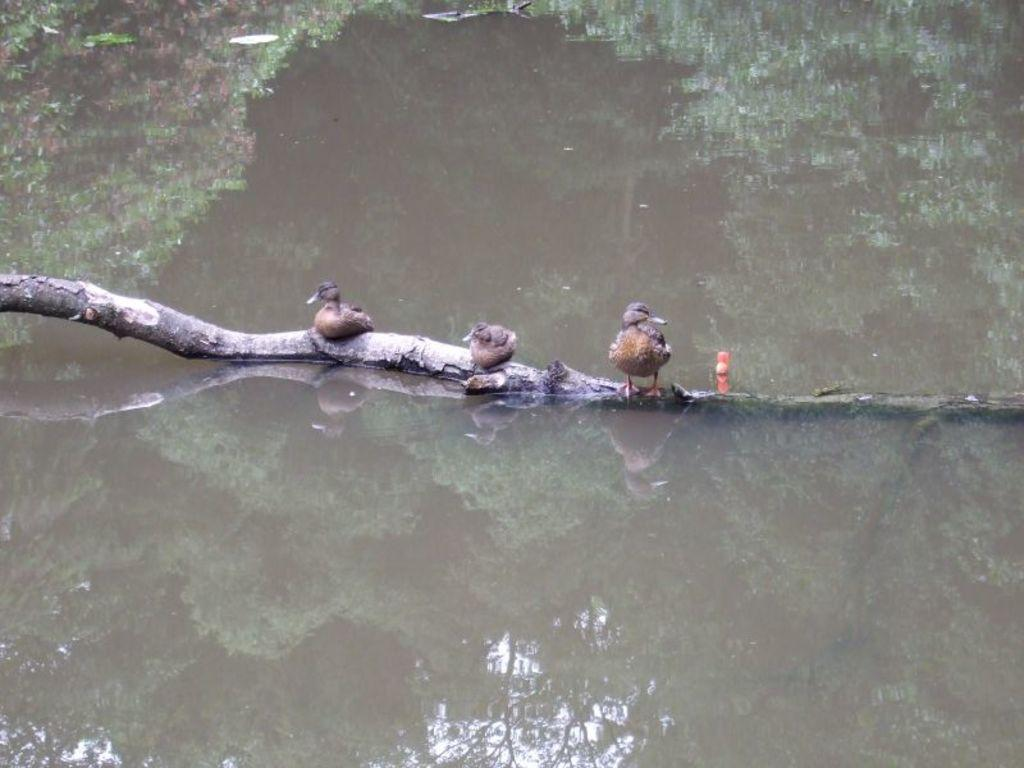How many birds are present in the image? There are three birds in the image. What are the birds standing on? The birds are standing on a wooden branch. What can be seen in the background of the image? There is a water surface visible in the image. What type of substance is the birds using to communicate with each other in the image? There is no indication in the image that the birds are using any substance to communicate. Additionally, birds do not typically use substances for communication. 